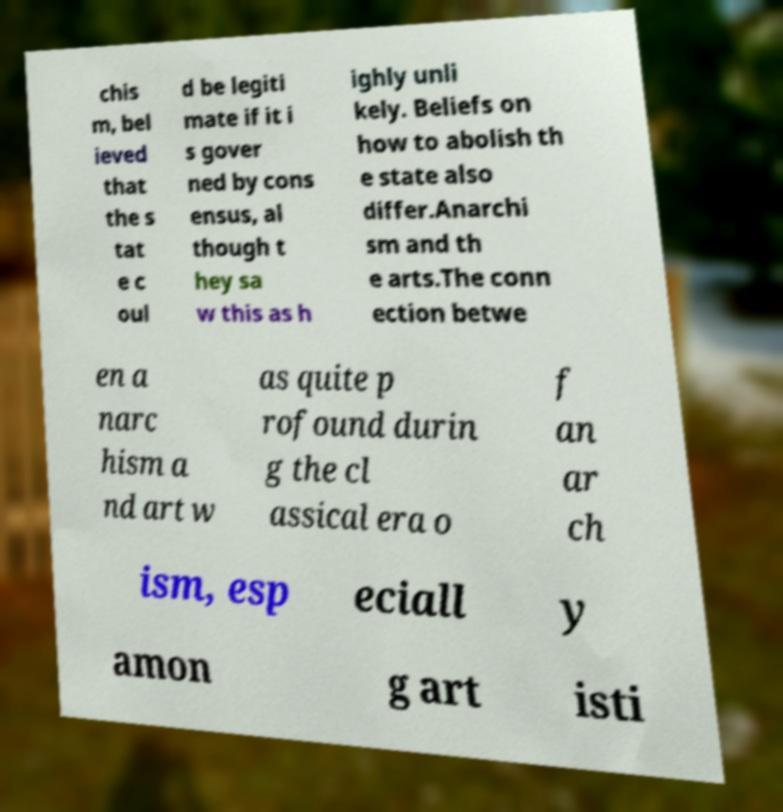Could you assist in decoding the text presented in this image and type it out clearly? chis m, bel ieved that the s tat e c oul d be legiti mate if it i s gover ned by cons ensus, al though t hey sa w this as h ighly unli kely. Beliefs on how to abolish th e state also differ.Anarchi sm and th e arts.The conn ection betwe en a narc hism a nd art w as quite p rofound durin g the cl assical era o f an ar ch ism, esp eciall y amon g art isti 